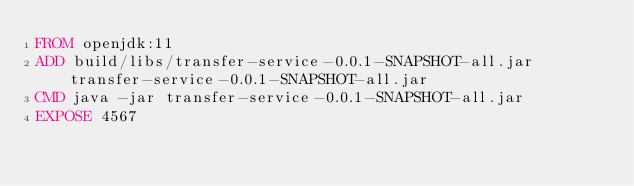Convert code to text. <code><loc_0><loc_0><loc_500><loc_500><_Dockerfile_>FROM openjdk:11
ADD build/libs/transfer-service-0.0.1-SNAPSHOT-all.jar transfer-service-0.0.1-SNAPSHOT-all.jar
CMD java -jar transfer-service-0.0.1-SNAPSHOT-all.jar
EXPOSE 4567
</code> 